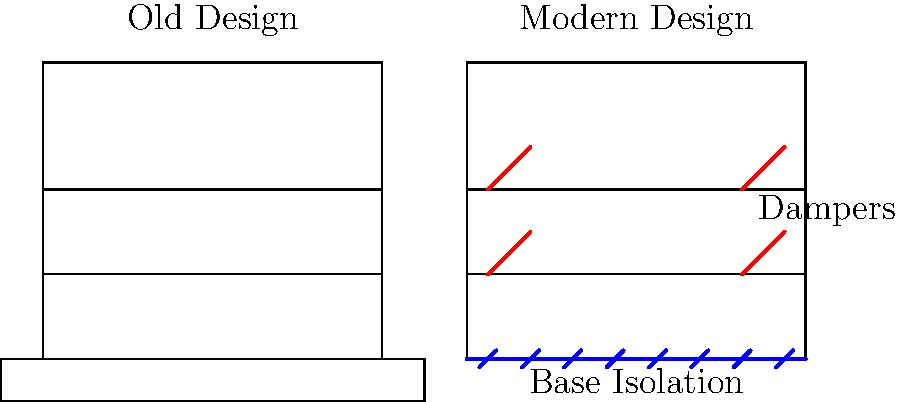As an art historian with an appreciation for architectural evolution, analyze the cross-sectional diagrams of two building designs. What key features in the modern design represent significant advancements in earthquake-resistant building techniques, and how might these innovations influence the aesthetic and functional aspects of contemporary architecture? To answer this question, let's examine the key features of the modern design and their implications:

1. Base Isolation:
   - Visible as blue lines and marks at the foundation level of the modern design.
   - Purpose: To isolate the building from ground motion during an earthquake.
   - Aesthetic impact: May result in a slight elevation of the building, creating a floating appearance.

2. Dampers:
   - Represented by red diagonal lines within the structure of the modern design.
   - Purpose: To absorb and dissipate energy from seismic waves.
   - Aesthetic impact: May be incorporated as visible elements, adding industrial or high-tech visual interest.

3. Flexible Structure:
   - While not explicitly shown, the modern design implies a more flexible overall structure.
   - Purpose: To allow the building to sway and absorb energy during an earthquake.
   - Aesthetic impact: Enables more creative and dynamic architectural forms.

These advancements influence contemporary architecture in several ways:

1. Form follows function: The integration of seismic technologies becomes a defining feature of the building's appearance.
2. Increased design freedom: Enhanced structural stability allows for more innovative and daring architectural expressions.
3. Cultural significance: Buildings embody the resilience and adaptability of modern society in earthquake-prone regions.
4. Preservation of artistic elements: Better protection of the building ensures the longevity of any artistic or historical features within.

As an art historian, you might appreciate how these technical advancements have opened new avenues for architectural expression while simultaneously preserving the integrity of buildings and their contents in seismically active areas.
Answer: Base isolation and dampers, allowing for increased design freedom and cultural expression of resilience. 